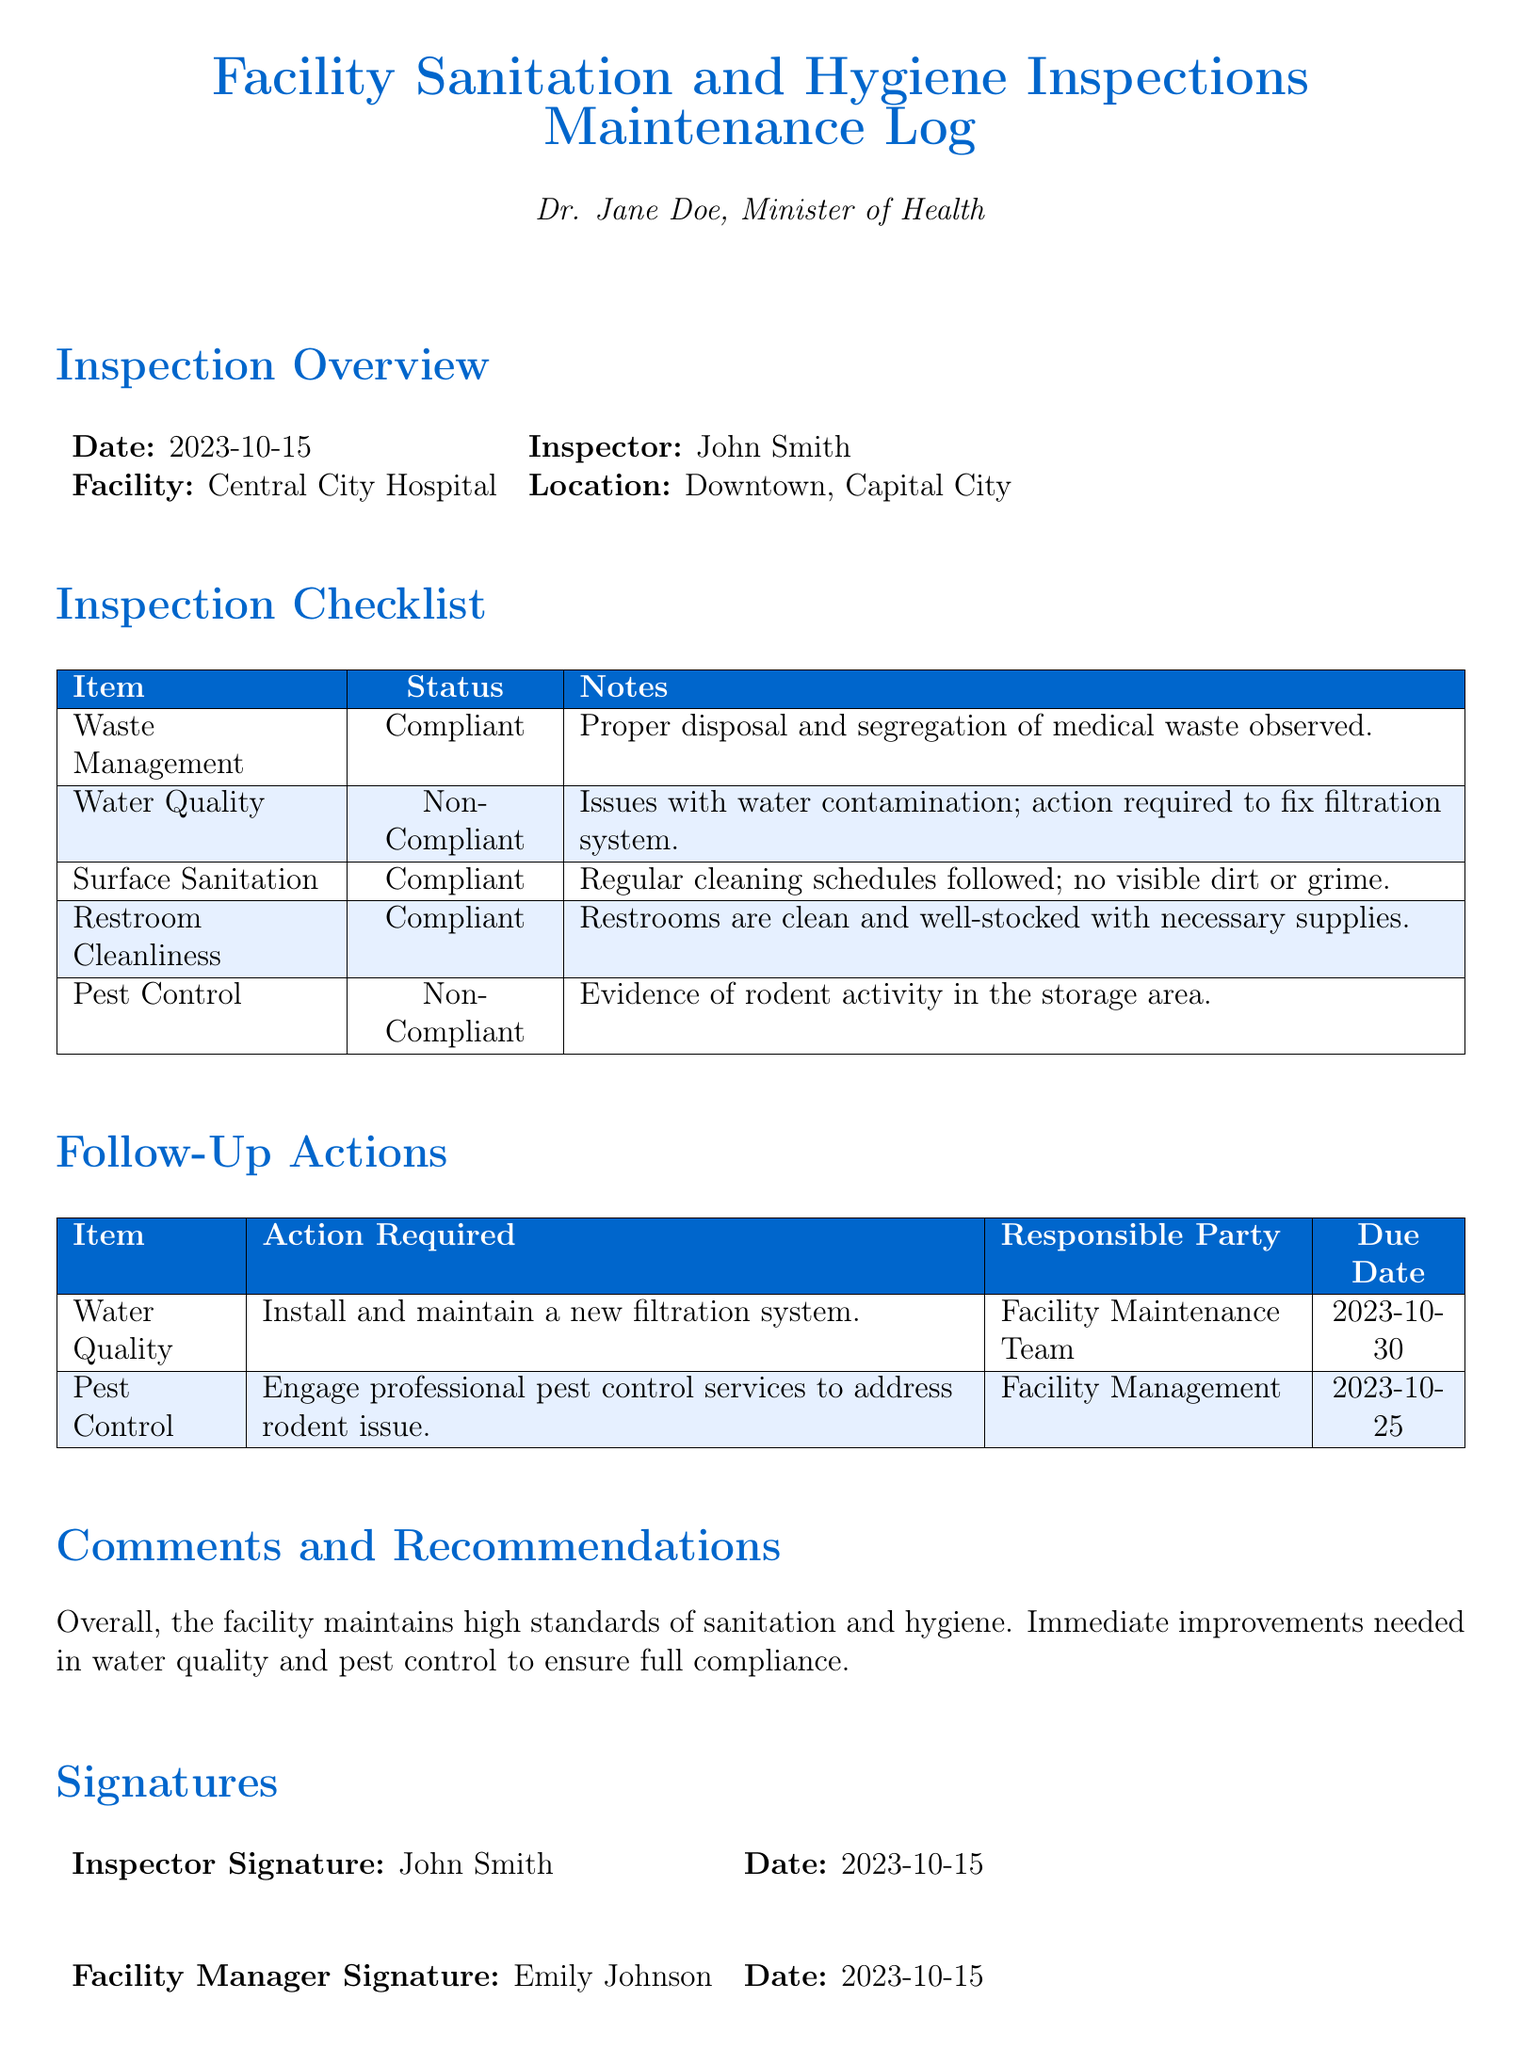What is the date of the inspection? The inspection date is stated clearly in the document.
Answer: 2023-10-15 Who conducted the inspection? The name of the inspector is provided in the document.
Answer: John Smith What is the compliance status of Water Quality? The compliance status for Water Quality is highlighted within the inspection checklist.
Answer: Non-Compliant What action is required for Pest Control? The follow-up actions section details what needs to be done for each non-compliant item.
Answer: Engage professional pest control services to address rodent issue What is the due date for installing a new filtration system? The due date for the action related to Water Quality is specified in the follow-up actions table.
Answer: 2023-10-30 How many items were marked as compliant? The checklist provides the status of each item, indicating how many are compliant.
Answer: 3 What is the signature date of the Facility Manager? The document includes the signature date for the Facility Manager.
Answer: 2023-10-15 What is noted about Surface Sanitation? The notes for each item provide insights into the current conditions and practices.
Answer: Regular cleaning schedules followed; no visible dirt or grime What is the location of the facility? The location is mentioned in the inspection overview section.
Answer: Downtown, Capital City 